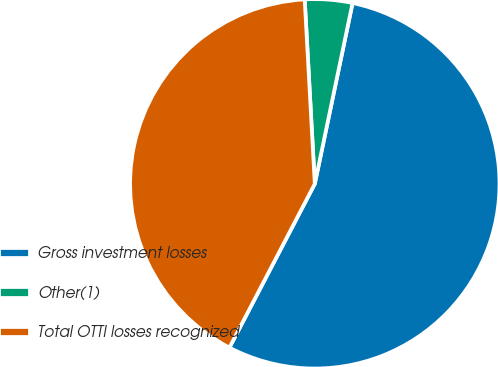<chart> <loc_0><loc_0><loc_500><loc_500><pie_chart><fcel>Gross investment losses<fcel>Other(1)<fcel>Total OTTI losses recognized<nl><fcel>54.37%<fcel>4.15%<fcel>41.48%<nl></chart> 